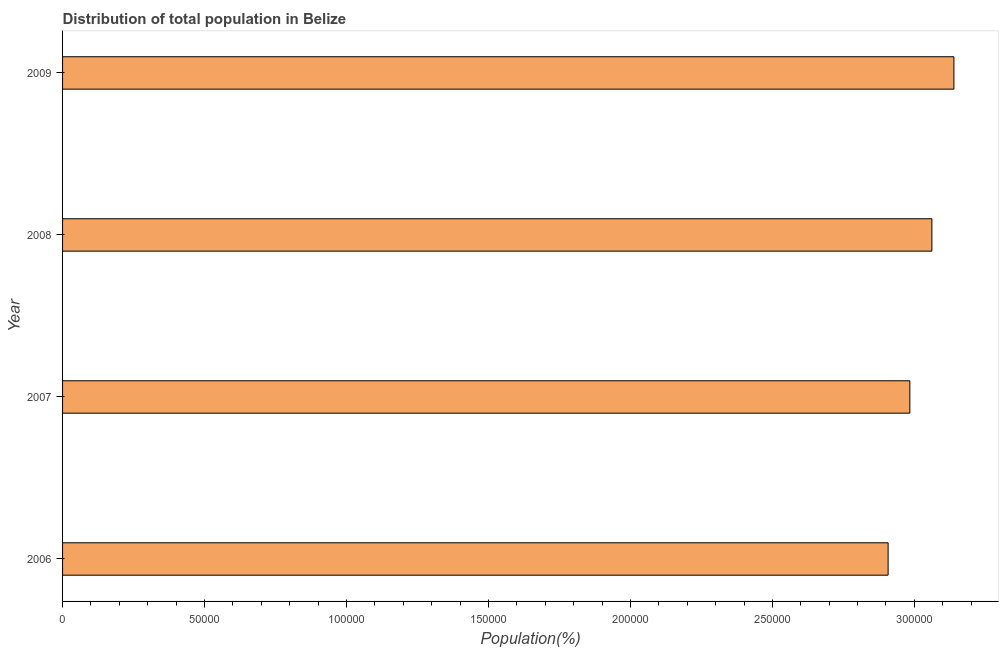Does the graph contain any zero values?
Provide a succinct answer. No. What is the title of the graph?
Your response must be concise. Distribution of total population in Belize . What is the label or title of the X-axis?
Ensure brevity in your answer.  Population(%). What is the population in 2006?
Offer a very short reply. 2.91e+05. Across all years, what is the maximum population?
Provide a succinct answer. 3.14e+05. Across all years, what is the minimum population?
Offer a terse response. 2.91e+05. In which year was the population minimum?
Ensure brevity in your answer.  2006. What is the sum of the population?
Provide a succinct answer. 1.21e+06. What is the difference between the population in 2006 and 2009?
Provide a short and direct response. -2.32e+04. What is the average population per year?
Ensure brevity in your answer.  3.02e+05. What is the median population?
Ensure brevity in your answer.  3.02e+05. In how many years, is the population greater than 50000 %?
Offer a terse response. 4. Do a majority of the years between 2008 and 2006 (inclusive) have population greater than 190000 %?
Ensure brevity in your answer.  Yes. What is the difference between the highest and the second highest population?
Provide a short and direct response. 7760. Is the sum of the population in 2007 and 2009 greater than the maximum population across all years?
Your answer should be compact. Yes. What is the difference between the highest and the lowest population?
Provide a succinct answer. 2.32e+04. In how many years, is the population greater than the average population taken over all years?
Provide a succinct answer. 2. How many years are there in the graph?
Provide a short and direct response. 4. What is the difference between two consecutive major ticks on the X-axis?
Your answer should be compact. 5.00e+04. Are the values on the major ticks of X-axis written in scientific E-notation?
Your answer should be compact. No. What is the Population(%) of 2006?
Your answer should be very brief. 2.91e+05. What is the Population(%) in 2007?
Keep it short and to the point. 2.98e+05. What is the Population(%) of 2008?
Give a very brief answer. 3.06e+05. What is the Population(%) in 2009?
Provide a succinct answer. 3.14e+05. What is the difference between the Population(%) in 2006 and 2007?
Provide a succinct answer. -7652. What is the difference between the Population(%) in 2006 and 2008?
Your response must be concise. -1.54e+04. What is the difference between the Population(%) in 2006 and 2009?
Your response must be concise. -2.32e+04. What is the difference between the Population(%) in 2007 and 2008?
Give a very brief answer. -7762. What is the difference between the Population(%) in 2007 and 2009?
Ensure brevity in your answer.  -1.55e+04. What is the difference between the Population(%) in 2008 and 2009?
Provide a short and direct response. -7760. What is the ratio of the Population(%) in 2006 to that in 2007?
Make the answer very short. 0.97. What is the ratio of the Population(%) in 2006 to that in 2008?
Offer a terse response. 0.95. What is the ratio of the Population(%) in 2006 to that in 2009?
Offer a very short reply. 0.93. What is the ratio of the Population(%) in 2007 to that in 2008?
Your answer should be very brief. 0.97. What is the ratio of the Population(%) in 2007 to that in 2009?
Your response must be concise. 0.95. What is the ratio of the Population(%) in 2008 to that in 2009?
Ensure brevity in your answer.  0.97. 